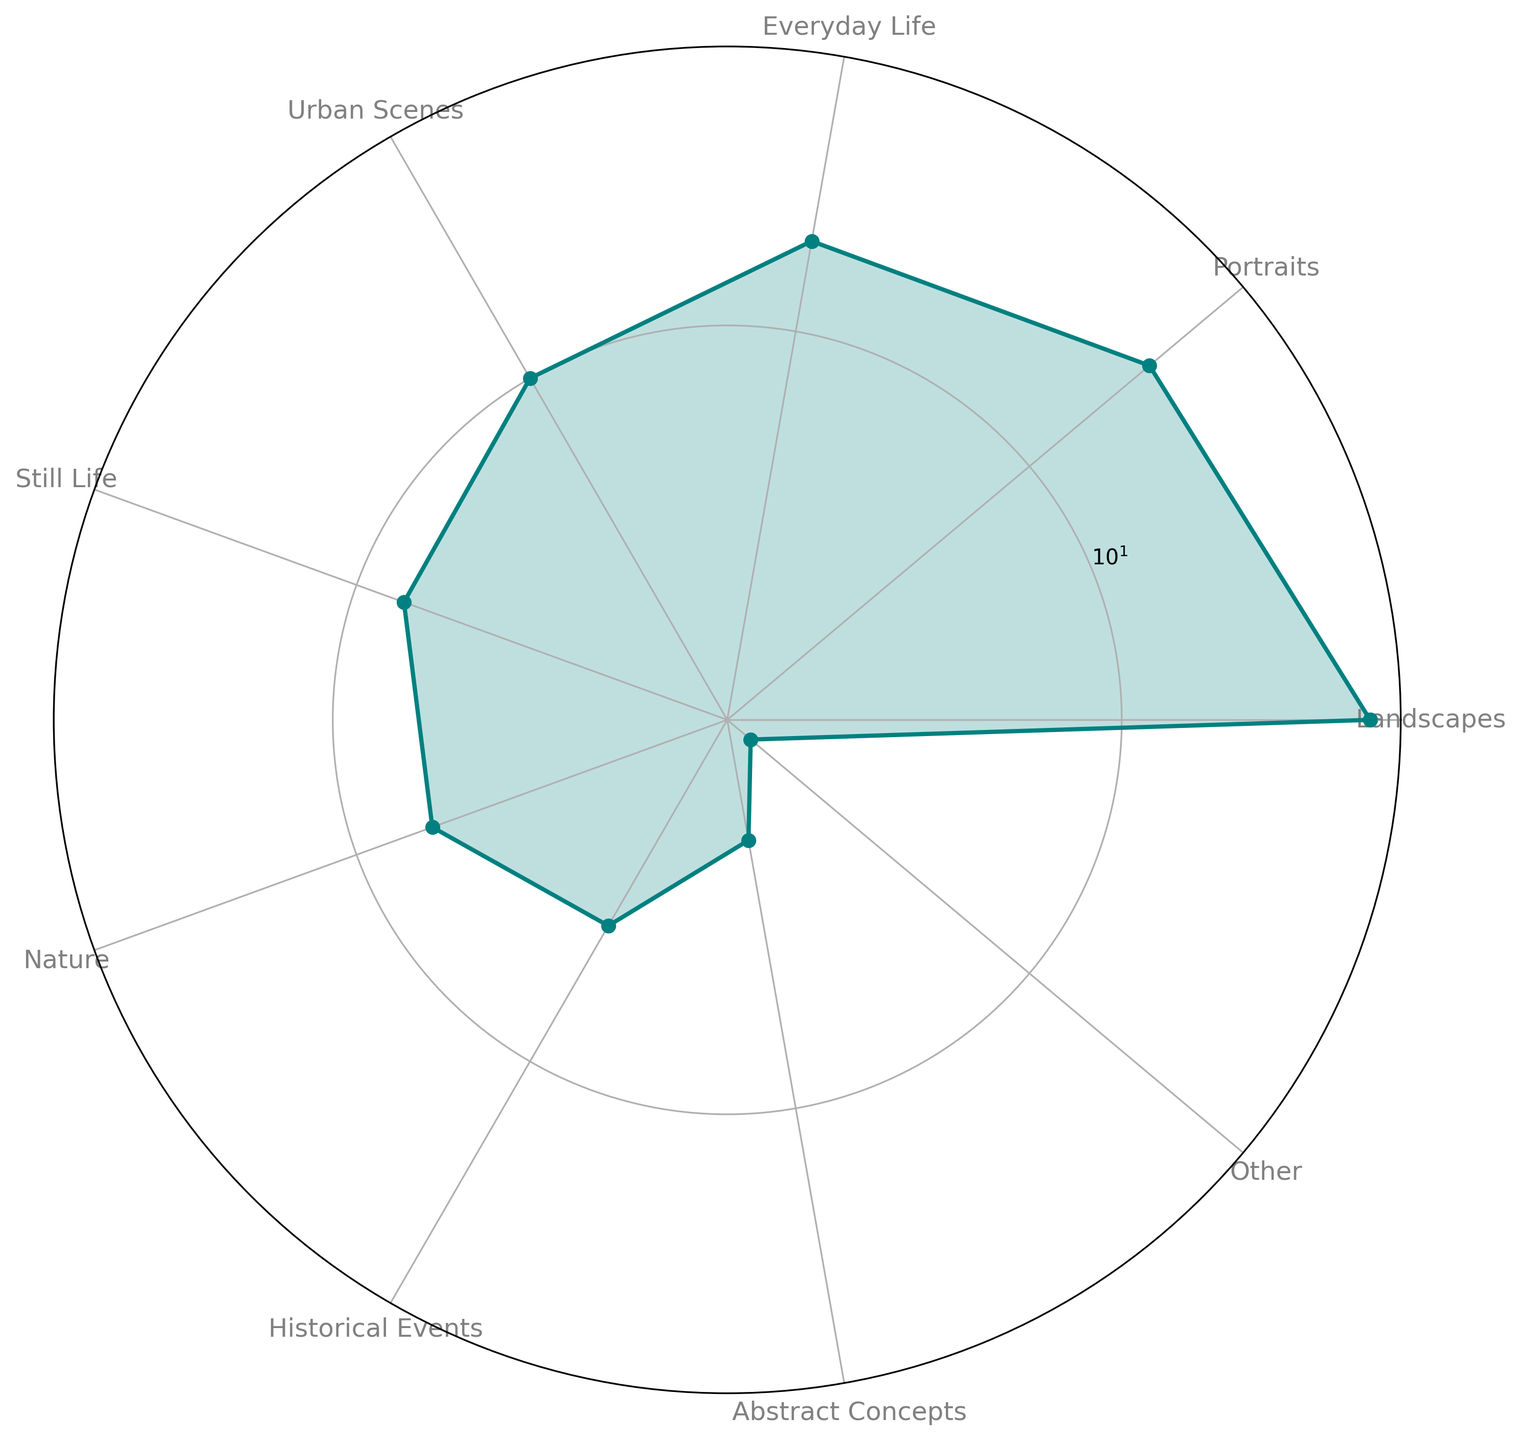Which theme has the highest representation in the chart? The theme with the highest representation can be identified by looking at the longest radial segment in the chart. The "Landscapes" theme has the highest representation with a percentage of 30.
Answer: Landscapes How does the percentage of "Portraits" compare to that of "Everyday Life"? We can compare the lengths of the radial segments for "Portraits" and "Everyday Life." The "Portraits" theme has a segment corresponding to 20%, whereas "Everyday Life" corresponds to 15%. Thus, "Portraits" has a higher percentage than "Everyday Life."
Answer: Portraits have a higher percentage What is the combined percentage of the themes "Urban Scenes," "Still Life," and "Nature"? To find the combined percentage, add the percentages of these three themes: Urban Scenes (10%), Still Life (8%), and Nature (7%). The combined percentage is 10 + 8 + 7 = 25%.
Answer: 25% Which theme has the smallest representation, and what is its percentage? The theme with the smallest representation can be identified by the shortest radial segment in the chart. The "Other" theme has the smallest representation with a percentage of 2.
Answer: Other, 2% Are there more historical or abstract representations in Impressionist artworks? Compare the percentages of the "Historical Events" and "Abstract Concepts" segments. Historical Events have a percentage of 5%, and Abstract Concepts have a percentage of 3%. Therefore, there are more historical representations.
Answer: Historical Events What is the difference in percentage between the most and the least represented themes? Subtract the percentage of the least represented theme ("Other" at 2%) from the most represented theme ("Landscapes" at 30%) to find the difference. The difference is 30 - 2 = 28%.
Answer: 28% What is the total percentage for the top three themes? The top three themes based on percentages are "Landscapes" (30%), "Portraits" (20%), and "Everyday Life" (15%). Adding these together gives 30 + 20 + 15 = 65%.
Answer: 65% Which is more common, "Nature" or "Still Life"? Compare the lengths of the radial segments for "Nature" and "Still Life." Nature has a percentage of 7%, while Still Life has 8%. Thus, Still Life is more common.
Answer: Still Life What themes have a percentage less than 10%? The themes with percentages less than 10% are "Still Life" (8%), "Nature" (7%), "Historical Events" (5%), "Abstract Concepts" (3%), and "Other" (2%).
Answer: Still Life, Nature, Historical Events, Abstract Concepts, Other How does the contribution of "Urban Scenes" visually appear in comparison to "Landscapes"? Visually compare the radial segments for "Urban Scenes" and "Landscapes." The "Urban Scenes" segment is significantly shorter at 10% compared to the "Landscapes" segment at 30%. This shows that "Landscapes" dominate "Urban Scenes."
Answer: Landscapes are more dominant 